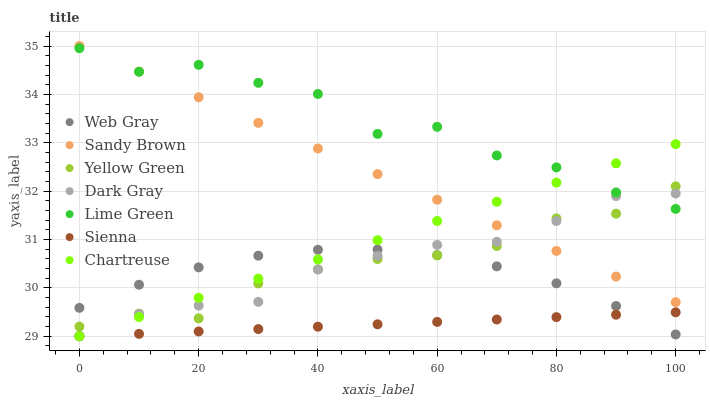Does Sienna have the minimum area under the curve?
Answer yes or no. Yes. Does Lime Green have the maximum area under the curve?
Answer yes or no. Yes. Does Web Gray have the minimum area under the curve?
Answer yes or no. No. Does Web Gray have the maximum area under the curve?
Answer yes or no. No. Is Sandy Brown the smoothest?
Answer yes or no. Yes. Is Lime Green the roughest?
Answer yes or no. Yes. Is Web Gray the smoothest?
Answer yes or no. No. Is Web Gray the roughest?
Answer yes or no. No. Does Sienna have the lowest value?
Answer yes or no. Yes. Does Web Gray have the lowest value?
Answer yes or no. No. Does Sandy Brown have the highest value?
Answer yes or no. Yes. Does Web Gray have the highest value?
Answer yes or no. No. Is Sienna less than Lime Green?
Answer yes or no. Yes. Is Yellow Green greater than Sienna?
Answer yes or no. Yes. Does Yellow Green intersect Lime Green?
Answer yes or no. Yes. Is Yellow Green less than Lime Green?
Answer yes or no. No. Is Yellow Green greater than Lime Green?
Answer yes or no. No. Does Sienna intersect Lime Green?
Answer yes or no. No. 